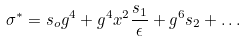Convert formula to latex. <formula><loc_0><loc_0><loc_500><loc_500>\sigma ^ { * } = s _ { o } g ^ { 4 } + g ^ { 4 } x ^ { 2 } \frac { s _ { 1 } } { \epsilon } + g ^ { 6 } s _ { 2 } + \dots</formula> 